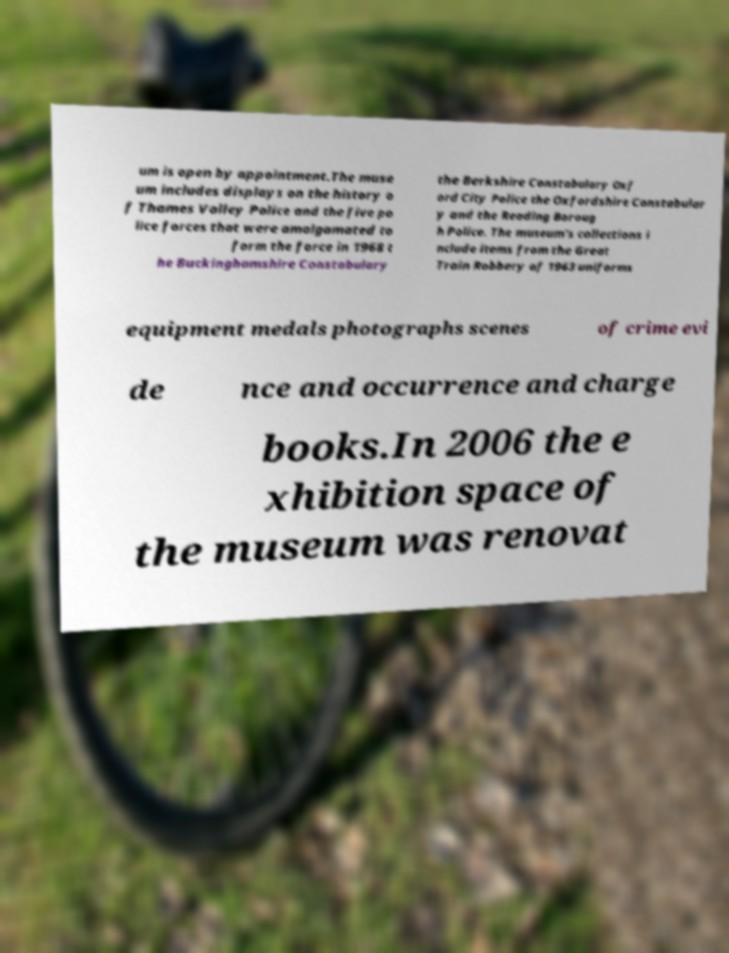What messages or text are displayed in this image? I need them in a readable, typed format. um is open by appointment.The muse um includes displays on the history o f Thames Valley Police and the five po lice forces that were amalgamated to form the force in 1968 t he Buckinghamshire Constabulary the Berkshire Constabulary Oxf ord City Police the Oxfordshire Constabular y and the Reading Boroug h Police. The museum's collections i nclude items from the Great Train Robbery of 1963 uniforms equipment medals photographs scenes of crime evi de nce and occurrence and charge books.In 2006 the e xhibition space of the museum was renovat 